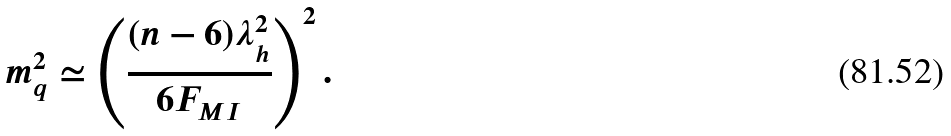<formula> <loc_0><loc_0><loc_500><loc_500>m ^ { 2 } _ { q } \simeq \left ( \frac { ( n - 6 ) \lambda _ { h } ^ { 2 } } { 6 F _ { M I } } \right ) ^ { 2 } .</formula> 